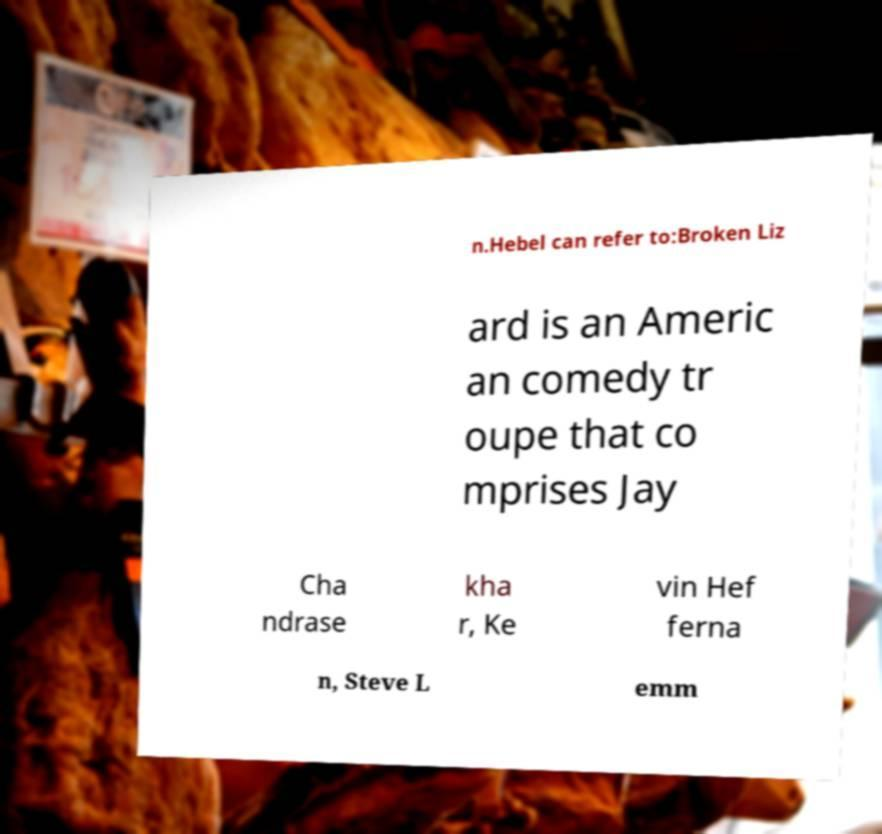Could you extract and type out the text from this image? n.Hebel can refer to:Broken Liz ard is an Americ an comedy tr oupe that co mprises Jay Cha ndrase kha r, Ke vin Hef ferna n, Steve L emm 